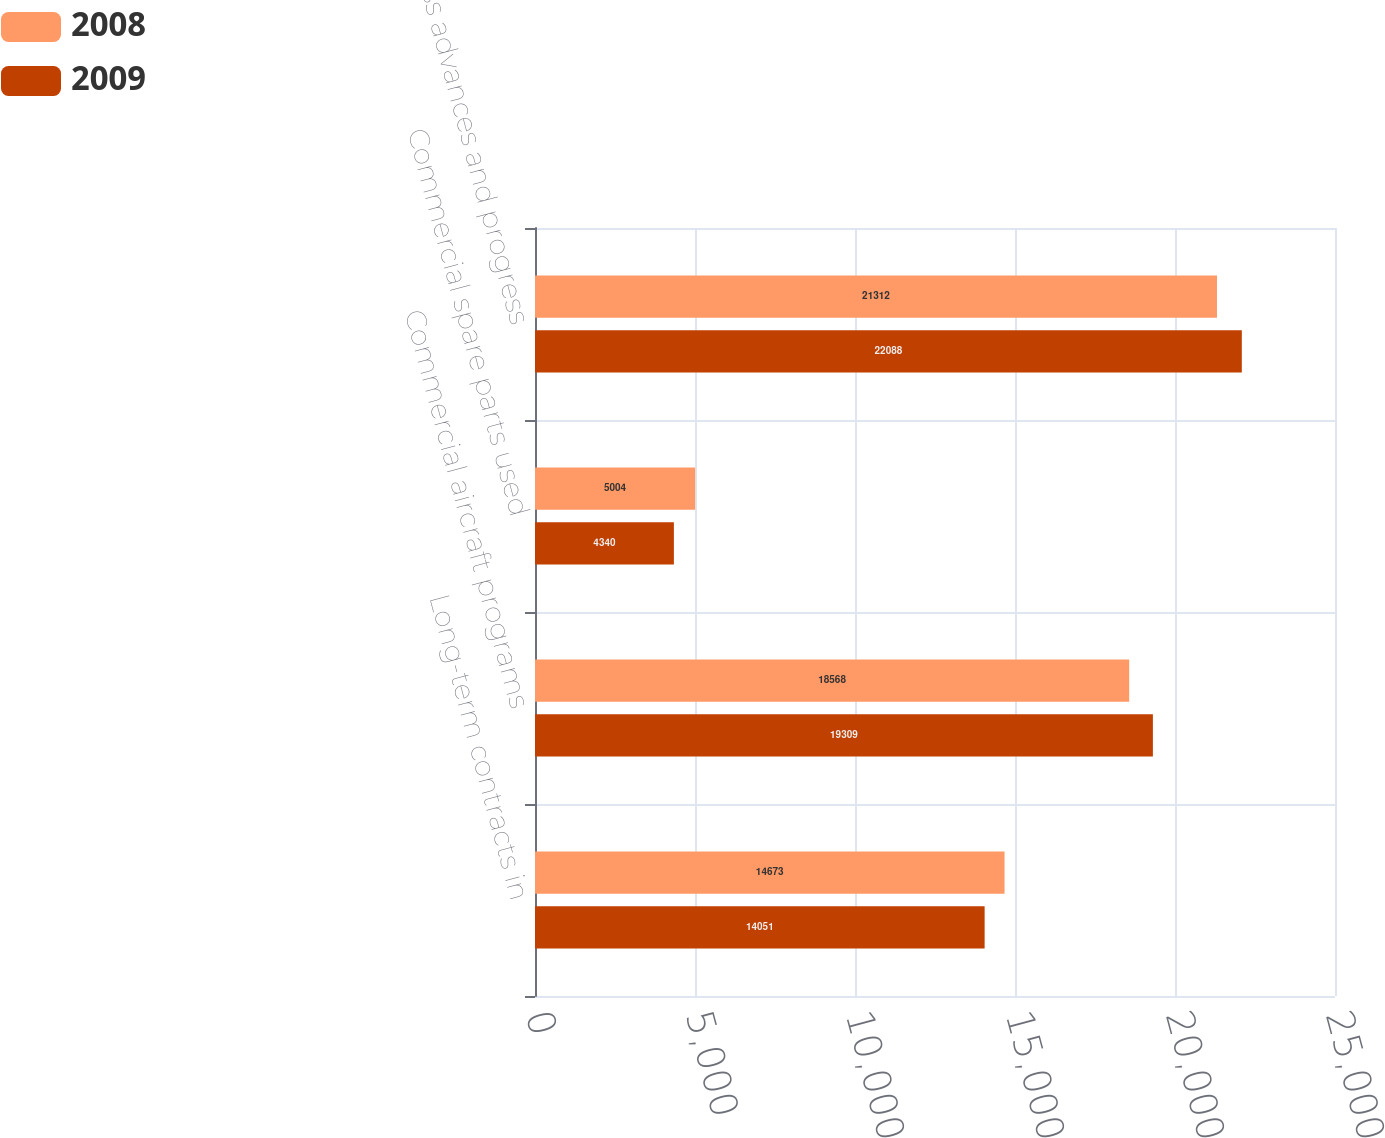Convert chart. <chart><loc_0><loc_0><loc_500><loc_500><stacked_bar_chart><ecel><fcel>Long-term contracts in<fcel>Commercial aircraft programs<fcel>Commercial spare parts used<fcel>Less advances and progress<nl><fcel>2008<fcel>14673<fcel>18568<fcel>5004<fcel>21312<nl><fcel>2009<fcel>14051<fcel>19309<fcel>4340<fcel>22088<nl></chart> 